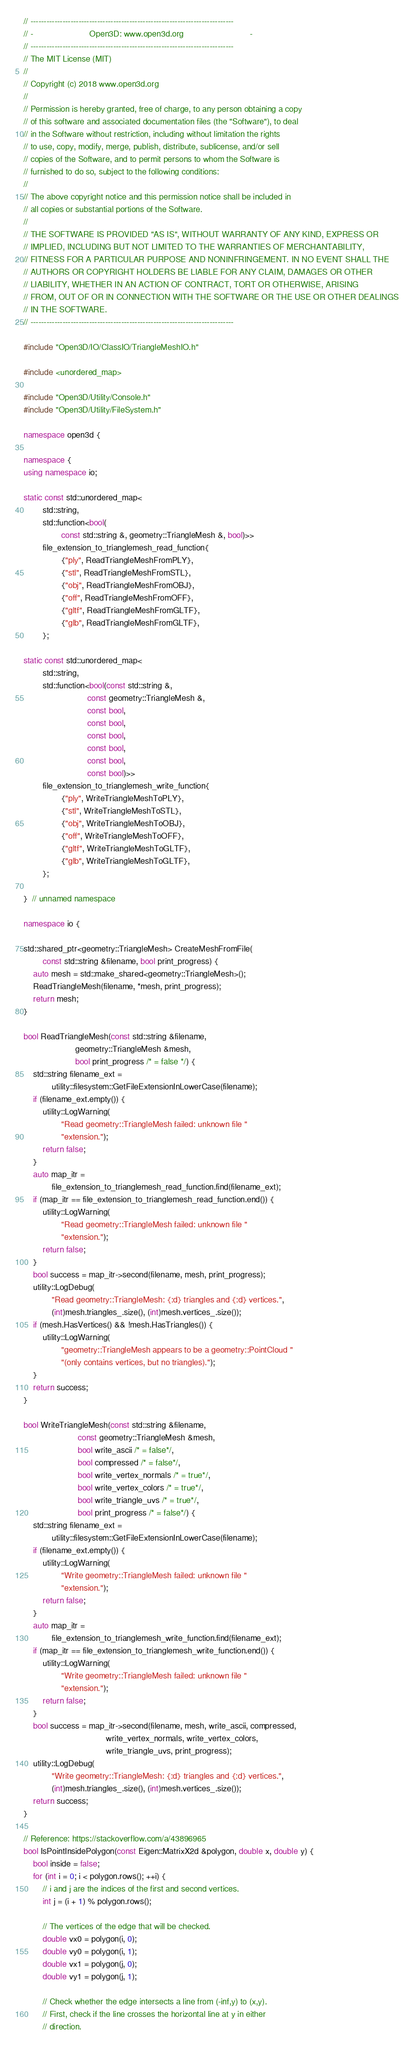Convert code to text. <code><loc_0><loc_0><loc_500><loc_500><_C++_>// ----------------------------------------------------------------------------
// -                        Open3D: www.open3d.org                            -
// ----------------------------------------------------------------------------
// The MIT License (MIT)
//
// Copyright (c) 2018 www.open3d.org
//
// Permission is hereby granted, free of charge, to any person obtaining a copy
// of this software and associated documentation files (the "Software"), to deal
// in the Software without restriction, including without limitation the rights
// to use, copy, modify, merge, publish, distribute, sublicense, and/or sell
// copies of the Software, and to permit persons to whom the Software is
// furnished to do so, subject to the following conditions:
//
// The above copyright notice and this permission notice shall be included in
// all copies or substantial portions of the Software.
//
// THE SOFTWARE IS PROVIDED "AS IS", WITHOUT WARRANTY OF ANY KIND, EXPRESS OR
// IMPLIED, INCLUDING BUT NOT LIMITED TO THE WARRANTIES OF MERCHANTABILITY,
// FITNESS FOR A PARTICULAR PURPOSE AND NONINFRINGEMENT. IN NO EVENT SHALL THE
// AUTHORS OR COPYRIGHT HOLDERS BE LIABLE FOR ANY CLAIM, DAMAGES OR OTHER
// LIABILITY, WHETHER IN AN ACTION OF CONTRACT, TORT OR OTHERWISE, ARISING
// FROM, OUT OF OR IN CONNECTION WITH THE SOFTWARE OR THE USE OR OTHER DEALINGS
// IN THE SOFTWARE.
// ----------------------------------------------------------------------------

#include "Open3D/IO/ClassIO/TriangleMeshIO.h"

#include <unordered_map>

#include "Open3D/Utility/Console.h"
#include "Open3D/Utility/FileSystem.h"

namespace open3d {

namespace {
using namespace io;

static const std::unordered_map<
        std::string,
        std::function<bool(
                const std::string &, geometry::TriangleMesh &, bool)>>
        file_extension_to_trianglemesh_read_function{
                {"ply", ReadTriangleMeshFromPLY},
                {"stl", ReadTriangleMeshFromSTL},
                {"obj", ReadTriangleMeshFromOBJ},
                {"off", ReadTriangleMeshFromOFF},
                {"gltf", ReadTriangleMeshFromGLTF},
                {"glb", ReadTriangleMeshFromGLTF},
        };

static const std::unordered_map<
        std::string,
        std::function<bool(const std::string &,
                           const geometry::TriangleMesh &,
                           const bool,
                           const bool,
                           const bool,
                           const bool,
                           const bool,
                           const bool)>>
        file_extension_to_trianglemesh_write_function{
                {"ply", WriteTriangleMeshToPLY},
                {"stl", WriteTriangleMeshToSTL},
                {"obj", WriteTriangleMeshToOBJ},
                {"off", WriteTriangleMeshToOFF},
                {"gltf", WriteTriangleMeshToGLTF},
                {"glb", WriteTriangleMeshToGLTF},
        };

}  // unnamed namespace

namespace io {

std::shared_ptr<geometry::TriangleMesh> CreateMeshFromFile(
        const std::string &filename, bool print_progress) {
    auto mesh = std::make_shared<geometry::TriangleMesh>();
    ReadTriangleMesh(filename, *mesh, print_progress);
    return mesh;
}

bool ReadTriangleMesh(const std::string &filename,
                      geometry::TriangleMesh &mesh,
                      bool print_progress /* = false */) {
    std::string filename_ext =
            utility::filesystem::GetFileExtensionInLowerCase(filename);
    if (filename_ext.empty()) {
        utility::LogWarning(
                "Read geometry::TriangleMesh failed: unknown file "
                "extension.");
        return false;
    }
    auto map_itr =
            file_extension_to_trianglemesh_read_function.find(filename_ext);
    if (map_itr == file_extension_to_trianglemesh_read_function.end()) {
        utility::LogWarning(
                "Read geometry::TriangleMesh failed: unknown file "
                "extension.");
        return false;
    }
    bool success = map_itr->second(filename, mesh, print_progress);
    utility::LogDebug(
            "Read geometry::TriangleMesh: {:d} triangles and {:d} vertices.",
            (int)mesh.triangles_.size(), (int)mesh.vertices_.size());
    if (mesh.HasVertices() && !mesh.HasTriangles()) {
        utility::LogWarning(
                "geometry::TriangleMesh appears to be a geometry::PointCloud "
                "(only contains vertices, but no triangles).");
    }
    return success;
}

bool WriteTriangleMesh(const std::string &filename,
                       const geometry::TriangleMesh &mesh,
                       bool write_ascii /* = false*/,
                       bool compressed /* = false*/,
                       bool write_vertex_normals /* = true*/,
                       bool write_vertex_colors /* = true*/,
                       bool write_triangle_uvs /* = true*/,
                       bool print_progress /* = false*/) {
    std::string filename_ext =
            utility::filesystem::GetFileExtensionInLowerCase(filename);
    if (filename_ext.empty()) {
        utility::LogWarning(
                "Write geometry::TriangleMesh failed: unknown file "
                "extension.");
        return false;
    }
    auto map_itr =
            file_extension_to_trianglemesh_write_function.find(filename_ext);
    if (map_itr == file_extension_to_trianglemesh_write_function.end()) {
        utility::LogWarning(
                "Write geometry::TriangleMesh failed: unknown file "
                "extension.");
        return false;
    }
    bool success = map_itr->second(filename, mesh, write_ascii, compressed,
                                   write_vertex_normals, write_vertex_colors,
                                   write_triangle_uvs, print_progress);
    utility::LogDebug(
            "Write geometry::TriangleMesh: {:d} triangles and {:d} vertices.",
            (int)mesh.triangles_.size(), (int)mesh.vertices_.size());
    return success;
}

// Reference: https://stackoverflow.com/a/43896965
bool IsPointInsidePolygon(const Eigen::MatrixX2d &polygon, double x, double y) {
    bool inside = false;
    for (int i = 0; i < polygon.rows(); ++i) {
        // i and j are the indices of the first and second vertices.
        int j = (i + 1) % polygon.rows();

        // The vertices of the edge that will be checked.
        double vx0 = polygon(i, 0);
        double vy0 = polygon(i, 1);
        double vx1 = polygon(j, 0);
        double vy1 = polygon(j, 1);

        // Check whether the edge intersects a line from (-inf,y) to (x,y).
        // First, check if the line crosses the horizontal line at y in either
        // direction.</code> 